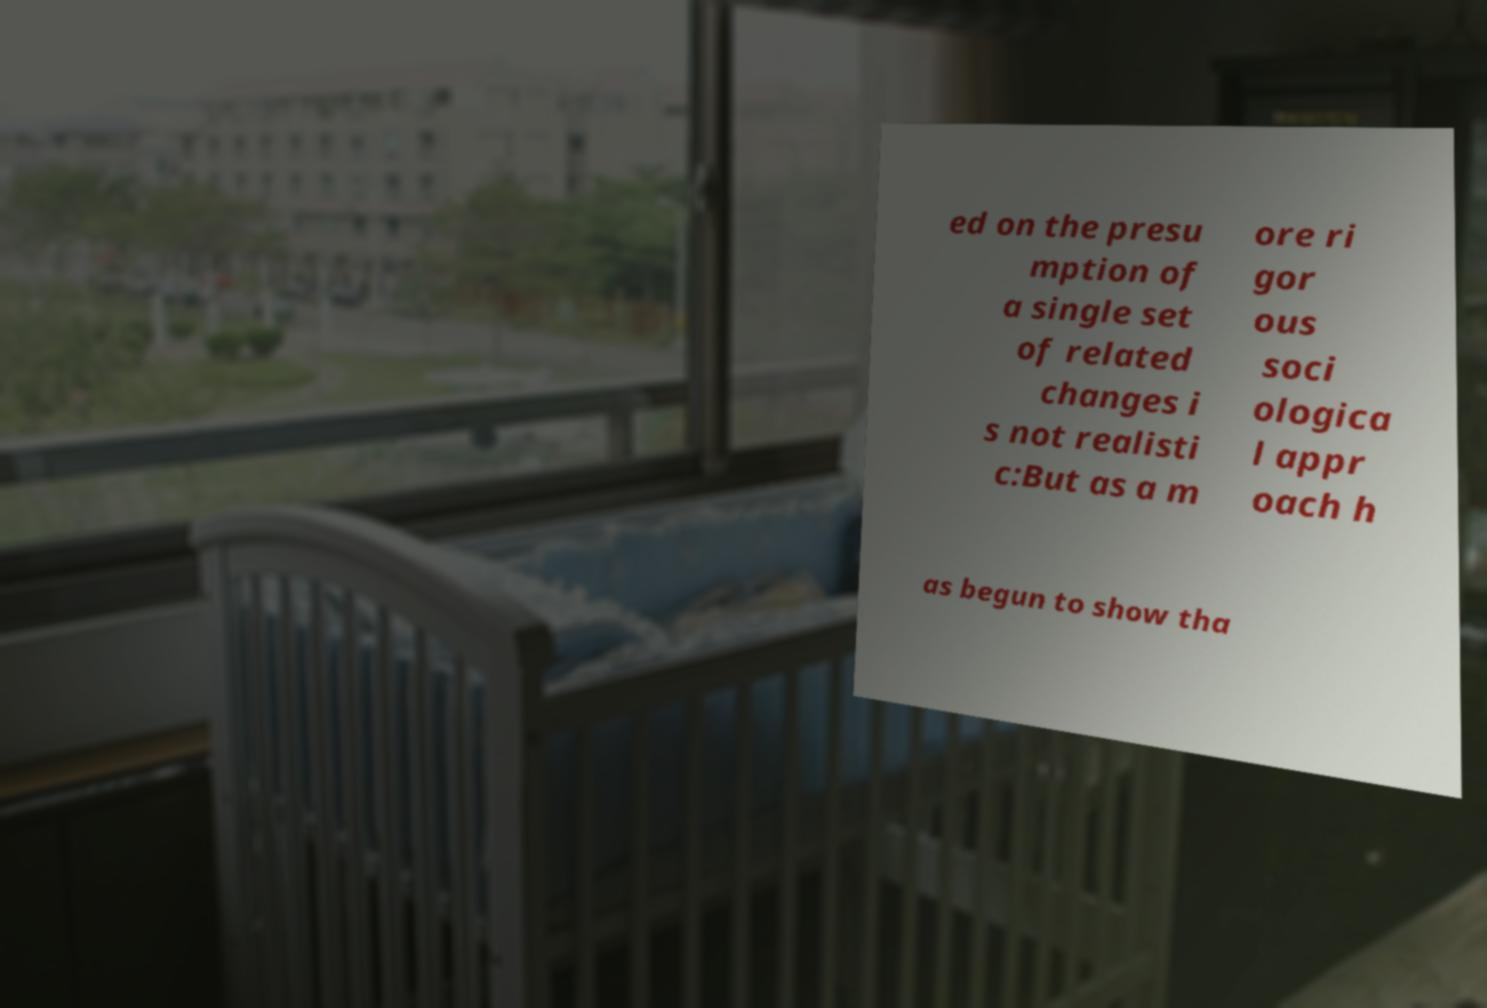For documentation purposes, I need the text within this image transcribed. Could you provide that? ed on the presu mption of a single set of related changes i s not realisti c:But as a m ore ri gor ous soci ologica l appr oach h as begun to show tha 